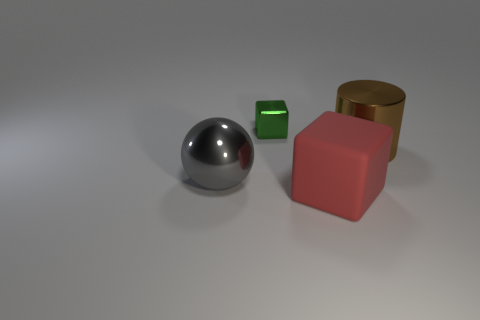Add 2 tiny shiny objects. How many objects exist? 6 Subtract all balls. How many objects are left? 3 Subtract all small shiny things. Subtract all small green metal blocks. How many objects are left? 2 Add 1 large spheres. How many large spheres are left? 2 Add 3 small purple matte cubes. How many small purple matte cubes exist? 3 Subtract 0 cyan cylinders. How many objects are left? 4 